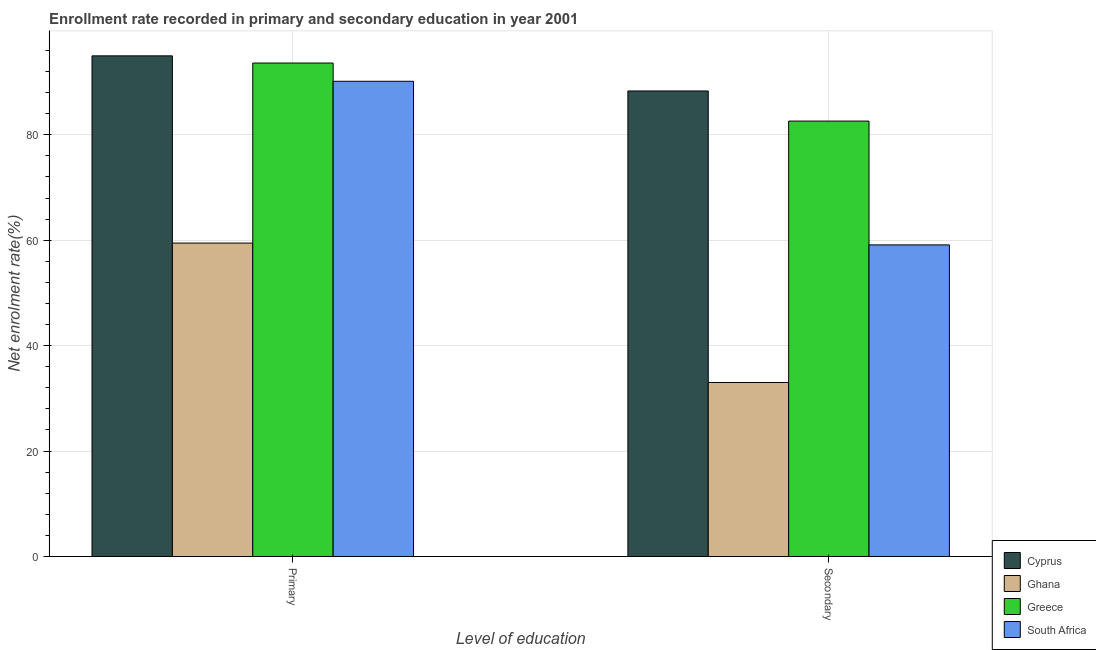Are the number of bars per tick equal to the number of legend labels?
Provide a succinct answer. Yes. What is the label of the 2nd group of bars from the left?
Offer a terse response. Secondary. What is the enrollment rate in secondary education in Cyprus?
Provide a short and direct response. 88.31. Across all countries, what is the maximum enrollment rate in primary education?
Give a very brief answer. 94.97. Across all countries, what is the minimum enrollment rate in secondary education?
Offer a terse response. 33.01. In which country was the enrollment rate in secondary education maximum?
Your answer should be compact. Cyprus. What is the total enrollment rate in primary education in the graph?
Ensure brevity in your answer.  338.18. What is the difference between the enrollment rate in secondary education in Greece and that in Ghana?
Make the answer very short. 49.58. What is the difference between the enrollment rate in primary education in Cyprus and the enrollment rate in secondary education in Ghana?
Offer a terse response. 61.96. What is the average enrollment rate in primary education per country?
Give a very brief answer. 84.55. What is the difference between the enrollment rate in secondary education and enrollment rate in primary education in Cyprus?
Your answer should be very brief. -6.66. What is the ratio of the enrollment rate in secondary education in South Africa to that in Greece?
Give a very brief answer. 0.72. Is the enrollment rate in primary education in South Africa less than that in Ghana?
Offer a terse response. No. How many countries are there in the graph?
Offer a terse response. 4. What is the difference between two consecutive major ticks on the Y-axis?
Your response must be concise. 20. Are the values on the major ticks of Y-axis written in scientific E-notation?
Your answer should be very brief. No. Does the graph contain any zero values?
Your response must be concise. No. Does the graph contain grids?
Provide a short and direct response. Yes. Where does the legend appear in the graph?
Keep it short and to the point. Bottom right. How many legend labels are there?
Your response must be concise. 4. How are the legend labels stacked?
Your answer should be compact. Vertical. What is the title of the graph?
Give a very brief answer. Enrollment rate recorded in primary and secondary education in year 2001. What is the label or title of the X-axis?
Ensure brevity in your answer.  Level of education. What is the label or title of the Y-axis?
Make the answer very short. Net enrolment rate(%). What is the Net enrolment rate(%) in Cyprus in Primary?
Your answer should be very brief. 94.97. What is the Net enrolment rate(%) in Ghana in Primary?
Make the answer very short. 59.46. What is the Net enrolment rate(%) in Greece in Primary?
Ensure brevity in your answer.  93.61. What is the Net enrolment rate(%) of South Africa in Primary?
Make the answer very short. 90.15. What is the Net enrolment rate(%) in Cyprus in Secondary?
Your answer should be very brief. 88.31. What is the Net enrolment rate(%) of Ghana in Secondary?
Keep it short and to the point. 33.01. What is the Net enrolment rate(%) of Greece in Secondary?
Your answer should be compact. 82.6. What is the Net enrolment rate(%) in South Africa in Secondary?
Make the answer very short. 59.11. Across all Level of education, what is the maximum Net enrolment rate(%) of Cyprus?
Provide a short and direct response. 94.97. Across all Level of education, what is the maximum Net enrolment rate(%) in Ghana?
Provide a succinct answer. 59.46. Across all Level of education, what is the maximum Net enrolment rate(%) in Greece?
Make the answer very short. 93.61. Across all Level of education, what is the maximum Net enrolment rate(%) in South Africa?
Ensure brevity in your answer.  90.15. Across all Level of education, what is the minimum Net enrolment rate(%) of Cyprus?
Provide a short and direct response. 88.31. Across all Level of education, what is the minimum Net enrolment rate(%) in Ghana?
Provide a succinct answer. 33.01. Across all Level of education, what is the minimum Net enrolment rate(%) in Greece?
Your response must be concise. 82.6. Across all Level of education, what is the minimum Net enrolment rate(%) in South Africa?
Provide a short and direct response. 59.11. What is the total Net enrolment rate(%) in Cyprus in the graph?
Your answer should be compact. 183.28. What is the total Net enrolment rate(%) in Ghana in the graph?
Your answer should be very brief. 92.47. What is the total Net enrolment rate(%) of Greece in the graph?
Keep it short and to the point. 176.2. What is the total Net enrolment rate(%) of South Africa in the graph?
Keep it short and to the point. 149.26. What is the difference between the Net enrolment rate(%) in Cyprus in Primary and that in Secondary?
Make the answer very short. 6.66. What is the difference between the Net enrolment rate(%) of Ghana in Primary and that in Secondary?
Your answer should be compact. 26.45. What is the difference between the Net enrolment rate(%) of Greece in Primary and that in Secondary?
Your answer should be compact. 11.01. What is the difference between the Net enrolment rate(%) in South Africa in Primary and that in Secondary?
Give a very brief answer. 31.04. What is the difference between the Net enrolment rate(%) of Cyprus in Primary and the Net enrolment rate(%) of Ghana in Secondary?
Your answer should be very brief. 61.96. What is the difference between the Net enrolment rate(%) of Cyprus in Primary and the Net enrolment rate(%) of Greece in Secondary?
Your response must be concise. 12.37. What is the difference between the Net enrolment rate(%) in Cyprus in Primary and the Net enrolment rate(%) in South Africa in Secondary?
Offer a terse response. 35.86. What is the difference between the Net enrolment rate(%) of Ghana in Primary and the Net enrolment rate(%) of Greece in Secondary?
Ensure brevity in your answer.  -23.14. What is the difference between the Net enrolment rate(%) of Ghana in Primary and the Net enrolment rate(%) of South Africa in Secondary?
Give a very brief answer. 0.35. What is the difference between the Net enrolment rate(%) in Greece in Primary and the Net enrolment rate(%) in South Africa in Secondary?
Your answer should be very brief. 34.5. What is the average Net enrolment rate(%) in Cyprus per Level of education?
Offer a very short reply. 91.64. What is the average Net enrolment rate(%) in Ghana per Level of education?
Your answer should be very brief. 46.23. What is the average Net enrolment rate(%) of Greece per Level of education?
Your response must be concise. 88.1. What is the average Net enrolment rate(%) in South Africa per Level of education?
Keep it short and to the point. 74.63. What is the difference between the Net enrolment rate(%) of Cyprus and Net enrolment rate(%) of Ghana in Primary?
Your answer should be compact. 35.51. What is the difference between the Net enrolment rate(%) in Cyprus and Net enrolment rate(%) in Greece in Primary?
Your answer should be compact. 1.36. What is the difference between the Net enrolment rate(%) in Cyprus and Net enrolment rate(%) in South Africa in Primary?
Offer a terse response. 4.82. What is the difference between the Net enrolment rate(%) in Ghana and Net enrolment rate(%) in Greece in Primary?
Provide a short and direct response. -34.15. What is the difference between the Net enrolment rate(%) in Ghana and Net enrolment rate(%) in South Africa in Primary?
Make the answer very short. -30.69. What is the difference between the Net enrolment rate(%) of Greece and Net enrolment rate(%) of South Africa in Primary?
Provide a succinct answer. 3.46. What is the difference between the Net enrolment rate(%) of Cyprus and Net enrolment rate(%) of Ghana in Secondary?
Ensure brevity in your answer.  55.3. What is the difference between the Net enrolment rate(%) of Cyprus and Net enrolment rate(%) of Greece in Secondary?
Your response must be concise. 5.71. What is the difference between the Net enrolment rate(%) in Cyprus and Net enrolment rate(%) in South Africa in Secondary?
Your response must be concise. 29.2. What is the difference between the Net enrolment rate(%) of Ghana and Net enrolment rate(%) of Greece in Secondary?
Your answer should be very brief. -49.58. What is the difference between the Net enrolment rate(%) of Ghana and Net enrolment rate(%) of South Africa in Secondary?
Keep it short and to the point. -26.1. What is the difference between the Net enrolment rate(%) of Greece and Net enrolment rate(%) of South Africa in Secondary?
Your response must be concise. 23.48. What is the ratio of the Net enrolment rate(%) in Cyprus in Primary to that in Secondary?
Ensure brevity in your answer.  1.08. What is the ratio of the Net enrolment rate(%) of Ghana in Primary to that in Secondary?
Provide a succinct answer. 1.8. What is the ratio of the Net enrolment rate(%) in Greece in Primary to that in Secondary?
Offer a very short reply. 1.13. What is the ratio of the Net enrolment rate(%) of South Africa in Primary to that in Secondary?
Offer a very short reply. 1.53. What is the difference between the highest and the second highest Net enrolment rate(%) of Cyprus?
Offer a terse response. 6.66. What is the difference between the highest and the second highest Net enrolment rate(%) in Ghana?
Give a very brief answer. 26.45. What is the difference between the highest and the second highest Net enrolment rate(%) of Greece?
Provide a short and direct response. 11.01. What is the difference between the highest and the second highest Net enrolment rate(%) of South Africa?
Your answer should be very brief. 31.04. What is the difference between the highest and the lowest Net enrolment rate(%) in Cyprus?
Make the answer very short. 6.66. What is the difference between the highest and the lowest Net enrolment rate(%) of Ghana?
Offer a terse response. 26.45. What is the difference between the highest and the lowest Net enrolment rate(%) in Greece?
Provide a succinct answer. 11.01. What is the difference between the highest and the lowest Net enrolment rate(%) in South Africa?
Offer a very short reply. 31.04. 